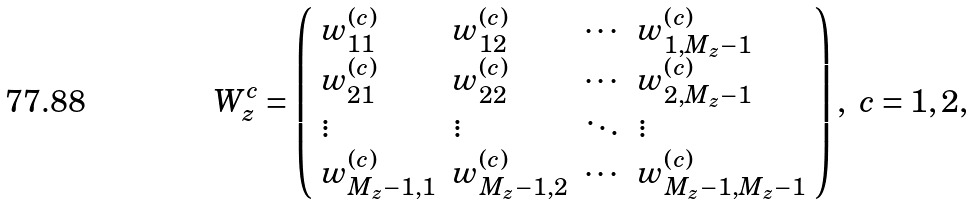Convert formula to latex. <formula><loc_0><loc_0><loc_500><loc_500>W ^ { c } _ { z } = \left ( \begin{array} { l l l l } w ^ { ( c ) } _ { 1 1 } & w ^ { ( c ) } _ { 1 2 } & \cdots & w ^ { ( c ) } _ { 1 , M _ { z } - 1 } \\ w ^ { ( c ) } _ { 2 1 } & w ^ { ( c ) } _ { 2 2 } & \cdots & w ^ { ( c ) } _ { 2 , M _ { z } - 1 } \\ \vdots & \vdots & \ddots & \vdots \\ w ^ { ( c ) } _ { M _ { z } - 1 , 1 } & w ^ { ( c ) } _ { M _ { z } - 1 , 2 } & \cdots & w ^ { ( c ) } _ { M _ { z } - 1 , M _ { z } - 1 } \end{array} \right ) , \ c = 1 , 2 ,</formula> 